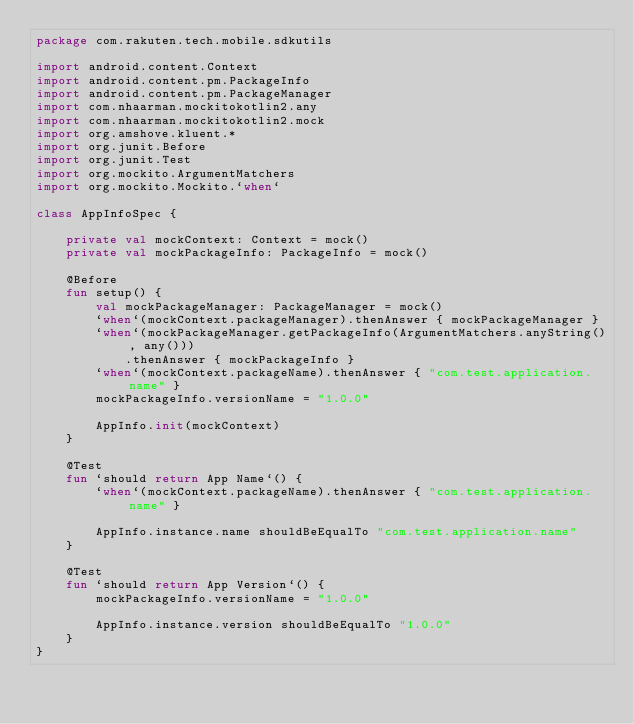<code> <loc_0><loc_0><loc_500><loc_500><_Kotlin_>package com.rakuten.tech.mobile.sdkutils

import android.content.Context
import android.content.pm.PackageInfo
import android.content.pm.PackageManager
import com.nhaarman.mockitokotlin2.any
import com.nhaarman.mockitokotlin2.mock
import org.amshove.kluent.*
import org.junit.Before
import org.junit.Test
import org.mockito.ArgumentMatchers
import org.mockito.Mockito.`when`

class AppInfoSpec {

    private val mockContext: Context = mock()
    private val mockPackageInfo: PackageInfo = mock()

    @Before
    fun setup() {
        val mockPackageManager: PackageManager = mock()
        `when`(mockContext.packageManager).thenAnswer { mockPackageManager }
        `when`(mockPackageManager.getPackageInfo(ArgumentMatchers.anyString(), any()))
            .thenAnswer { mockPackageInfo }
        `when`(mockContext.packageName).thenAnswer { "com.test.application.name" }
        mockPackageInfo.versionName = "1.0.0"

        AppInfo.init(mockContext)
    }

    @Test
    fun `should return App Name`() {
        `when`(mockContext.packageName).thenAnswer { "com.test.application.name" }

        AppInfo.instance.name shouldBeEqualTo "com.test.application.name"
    }

    @Test
    fun `should return App Version`() {
        mockPackageInfo.versionName = "1.0.0"

        AppInfo.instance.version shouldBeEqualTo "1.0.0"
    }
}</code> 